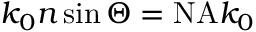<formula> <loc_0><loc_0><loc_500><loc_500>k _ { 0 } n \sin \Theta = N A k _ { 0 }</formula> 